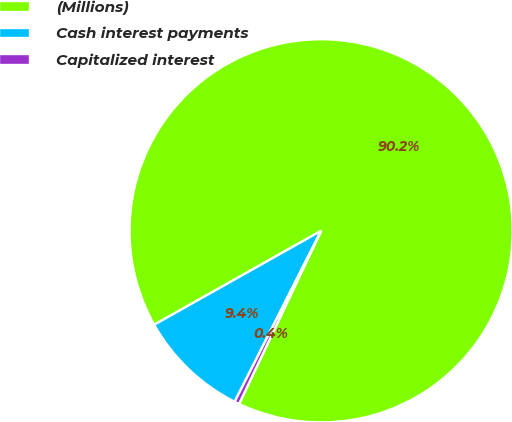Convert chart. <chart><loc_0><loc_0><loc_500><loc_500><pie_chart><fcel>(Millions)<fcel>Cash interest payments<fcel>Capitalized interest<nl><fcel>90.21%<fcel>9.39%<fcel>0.41%<nl></chart> 